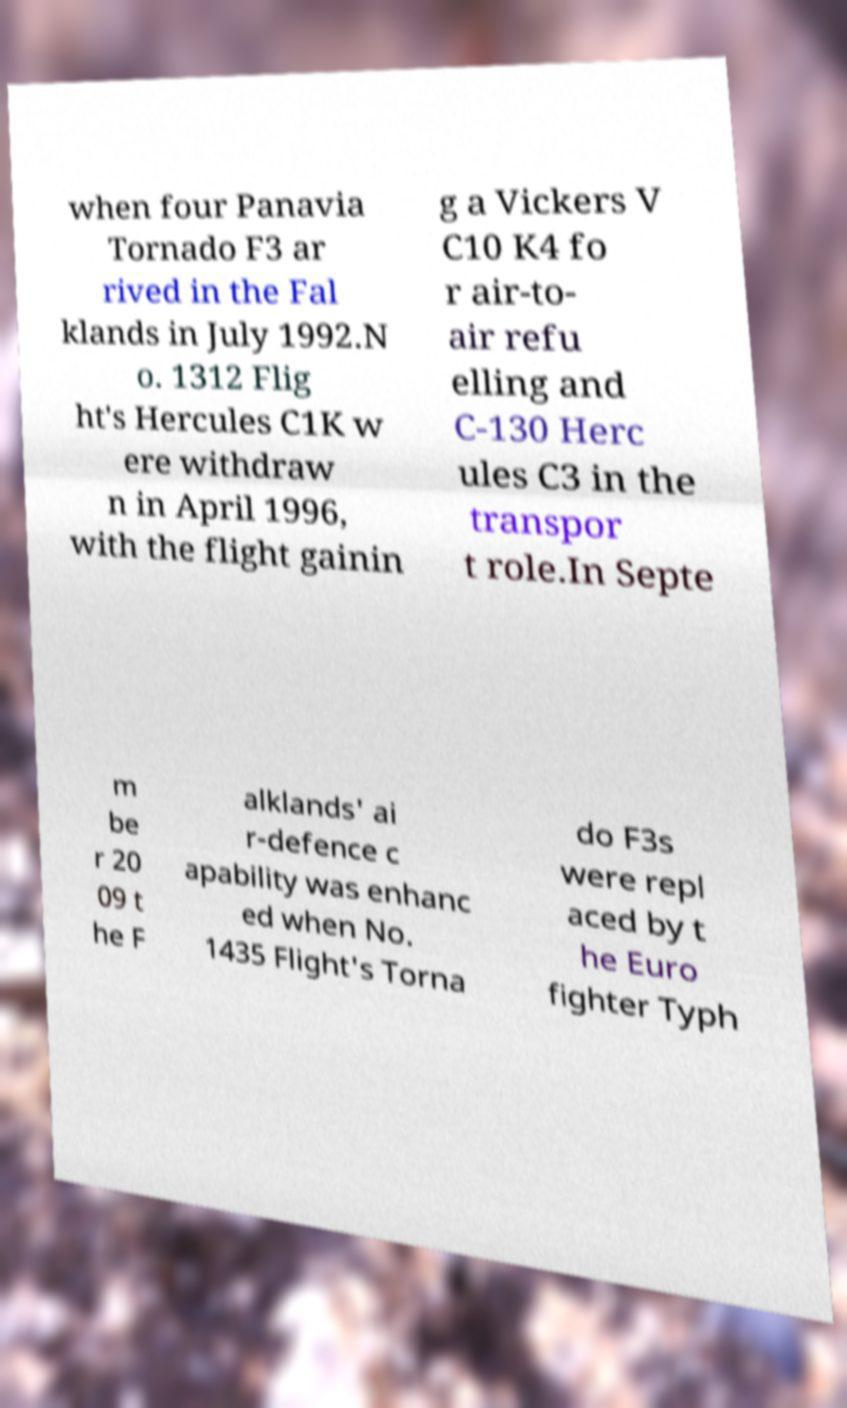What messages or text are displayed in this image? I need them in a readable, typed format. when four Panavia Tornado F3 ar rived in the Fal klands in July 1992.N o. 1312 Flig ht's Hercules C1K w ere withdraw n in April 1996, with the flight gainin g a Vickers V C10 K4 fo r air-to- air refu elling and C-130 Herc ules C3 in the transpor t role.In Septe m be r 20 09 t he F alklands' ai r-defence c apability was enhanc ed when No. 1435 Flight's Torna do F3s were repl aced by t he Euro fighter Typh 